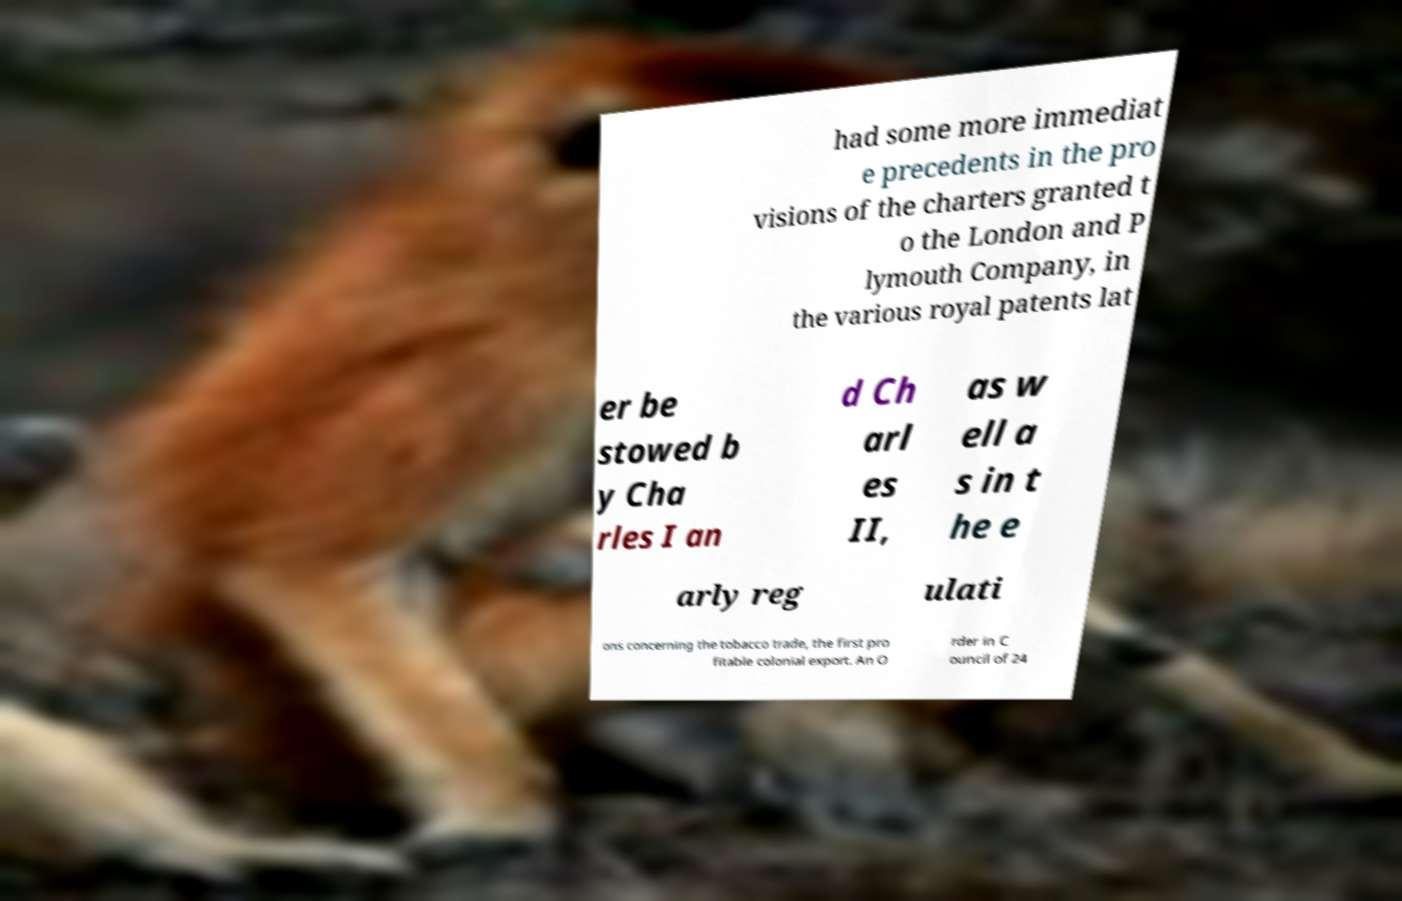For documentation purposes, I need the text within this image transcribed. Could you provide that? had some more immediat e precedents in the pro visions of the charters granted t o the London and P lymouth Company, in the various royal patents lat er be stowed b y Cha rles I an d Ch arl es II, as w ell a s in t he e arly reg ulati ons concerning the tobacco trade, the first pro fitable colonial export. An O rder in C ouncil of 24 